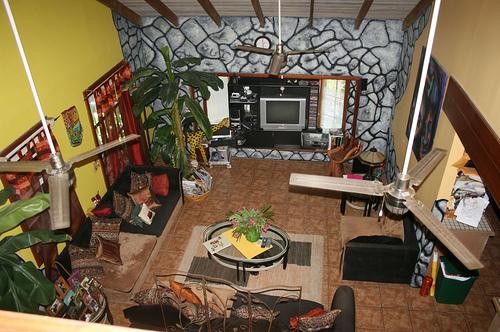Was this photo taken from upstairs?
Concise answer only. Yes. Is this a close up?
Be succinct. No. How many pieces of toy furniture are in the doll house?
Keep it brief. 20. What large plants are in the room?
Write a very short answer. Trees. How is air circulated?
Keep it brief. Fans. Do you think this shot was taken from a helicopter?
Give a very brief answer. No. 